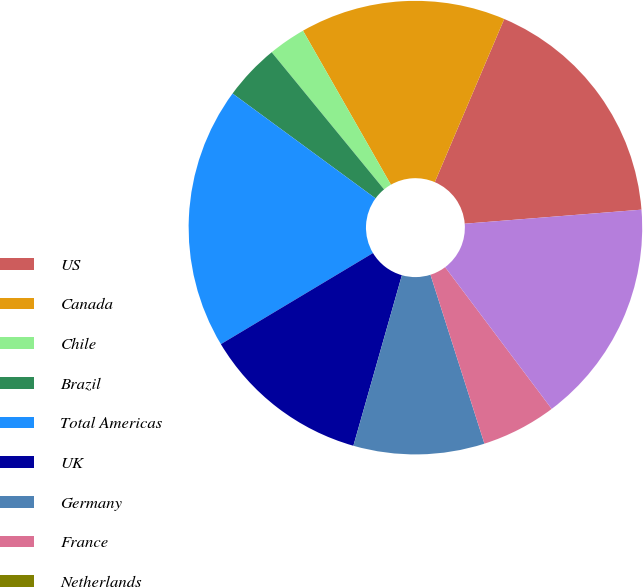<chart> <loc_0><loc_0><loc_500><loc_500><pie_chart><fcel>US<fcel>Canada<fcel>Chile<fcel>Brazil<fcel>Total Americas<fcel>UK<fcel>Germany<fcel>France<fcel>Netherlands<fcel>Total EMEA<nl><fcel>17.33%<fcel>14.66%<fcel>2.67%<fcel>4.0%<fcel>18.66%<fcel>12.0%<fcel>9.33%<fcel>5.34%<fcel>0.0%<fcel>16.0%<nl></chart> 